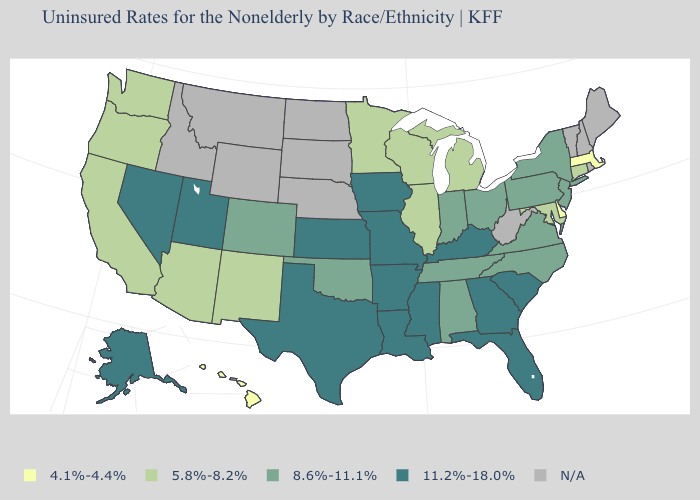What is the value of Maryland?
Give a very brief answer. 5.8%-8.2%. Name the states that have a value in the range 8.6%-11.1%?
Be succinct. Alabama, Colorado, Indiana, New Jersey, New York, North Carolina, Ohio, Oklahoma, Pennsylvania, Tennessee, Virginia. What is the value of North Carolina?
Quick response, please. 8.6%-11.1%. What is the value of Montana?
Keep it brief. N/A. Name the states that have a value in the range 8.6%-11.1%?
Answer briefly. Alabama, Colorado, Indiana, New Jersey, New York, North Carolina, Ohio, Oklahoma, Pennsylvania, Tennessee, Virginia. What is the value of Mississippi?
Answer briefly. 11.2%-18.0%. Among the states that border West Virginia , which have the lowest value?
Write a very short answer. Maryland. What is the value of Michigan?
Write a very short answer. 5.8%-8.2%. What is the highest value in states that border California?
Keep it brief. 11.2%-18.0%. Which states have the lowest value in the USA?
Give a very brief answer. Delaware, Hawaii, Massachusetts. Name the states that have a value in the range 5.8%-8.2%?
Quick response, please. Arizona, California, Connecticut, Illinois, Maryland, Michigan, Minnesota, New Mexico, Oregon, Washington, Wisconsin. Does Ohio have the highest value in the USA?
Quick response, please. No. What is the lowest value in states that border New Hampshire?
Keep it brief. 4.1%-4.4%. Does the first symbol in the legend represent the smallest category?
Concise answer only. Yes. What is the highest value in the USA?
Answer briefly. 11.2%-18.0%. 